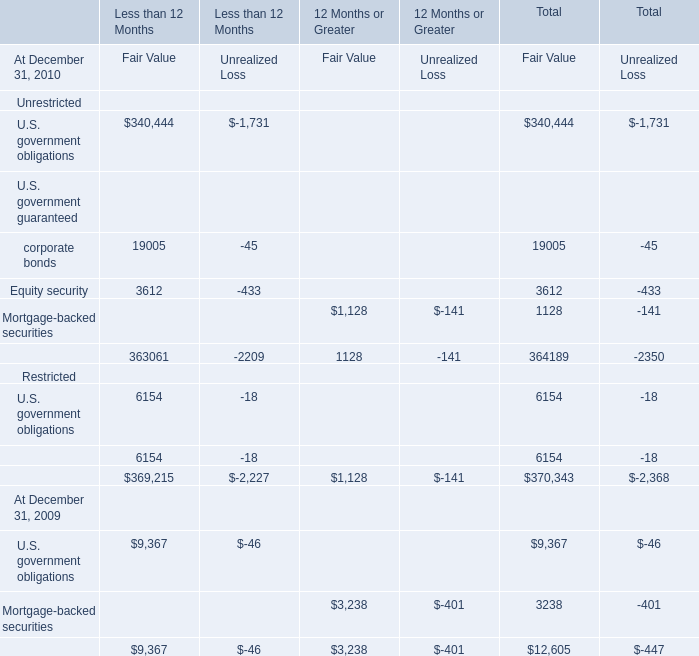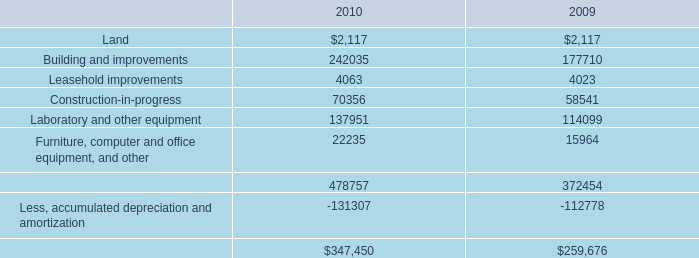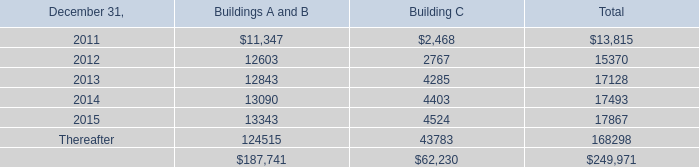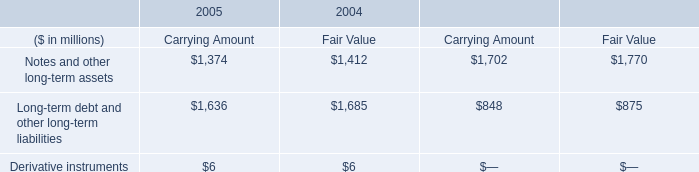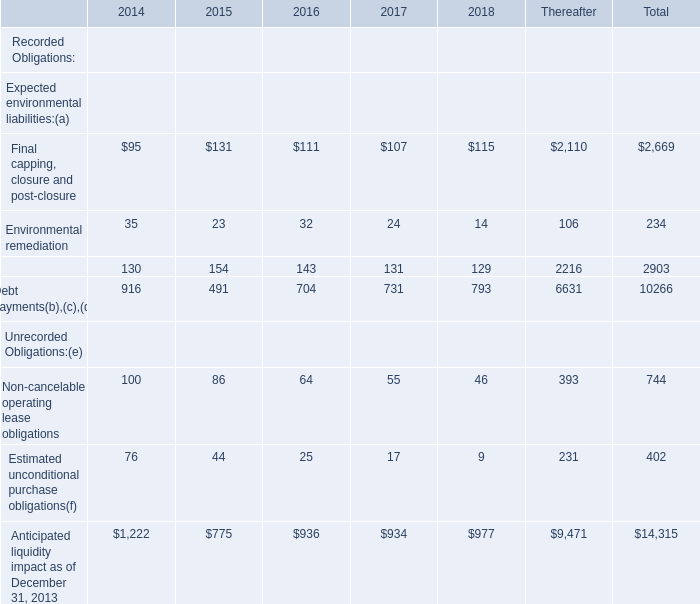What's the average of the U.S. government obligations for Fair Value for Less than 12 Months in the years where Building and improvements is greater than 0? 
Computations: (((340444 + 9367) + 6154) / 2)
Answer: 177982.5. 